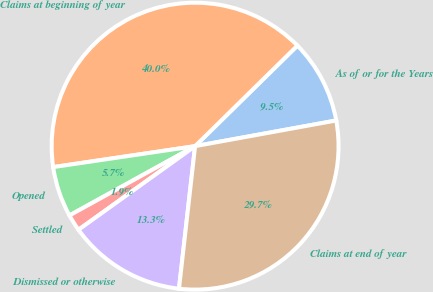<chart> <loc_0><loc_0><loc_500><loc_500><pie_chart><fcel>As of or for the Years<fcel>Claims at beginning of year<fcel>Opened<fcel>Settled<fcel>Dismissed or otherwise<fcel>Claims at end of year<nl><fcel>9.5%<fcel>39.98%<fcel>5.69%<fcel>1.88%<fcel>13.31%<fcel>29.66%<nl></chart> 